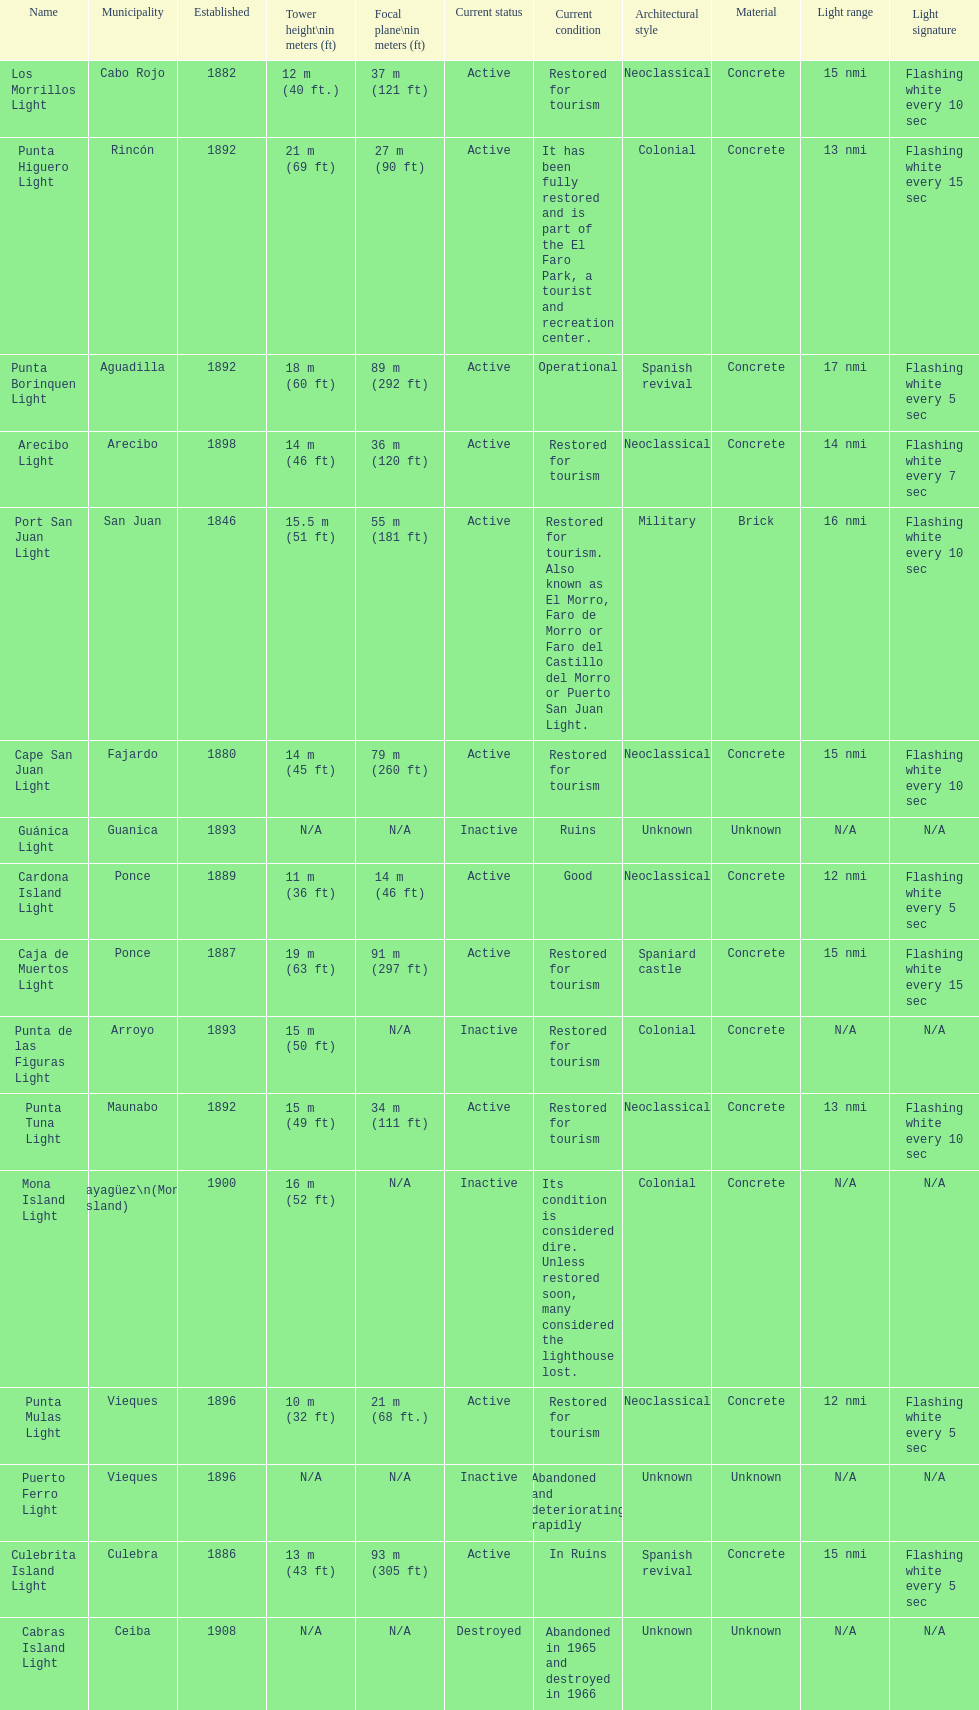How many towers are at least 18 meters tall? 3. 